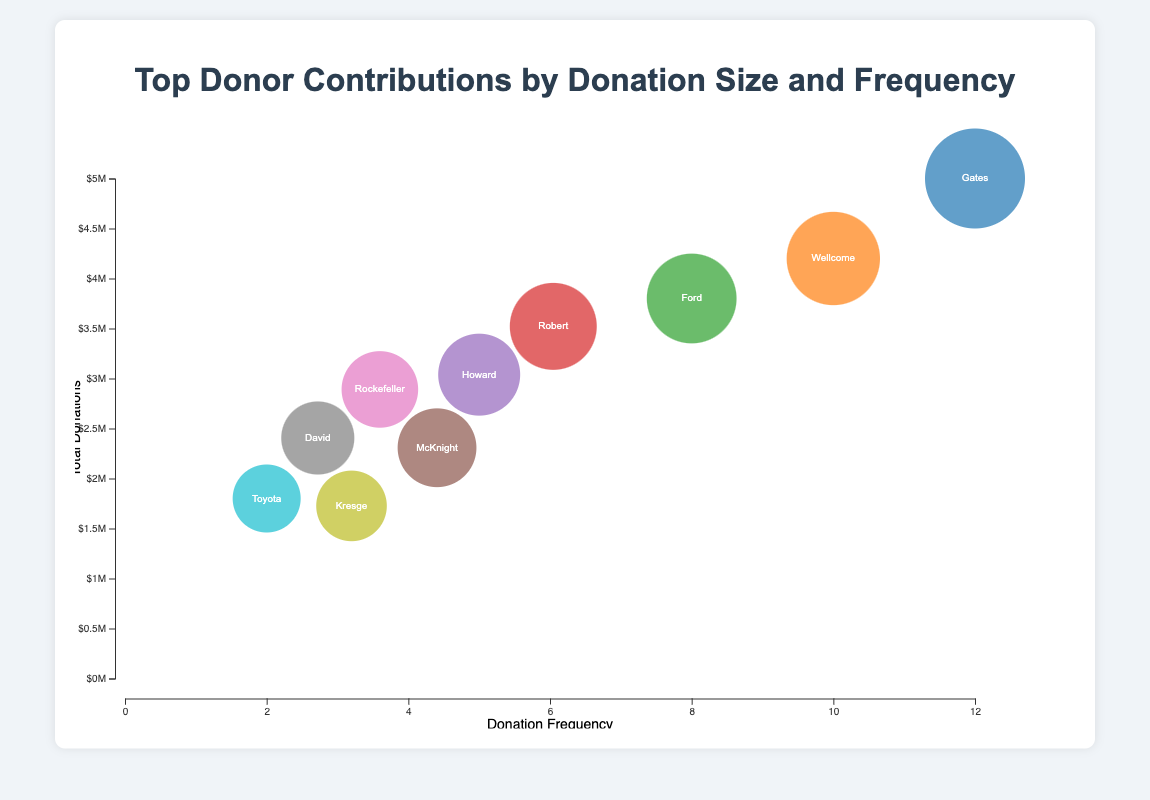What's the name of the donor with the highest total donations? The bubble chart shows various donors with different bubble sizes. The largest bubble represents the donor with the highest total donations. By identifying the largest bubble, which corresponds to the Gates Foundation, we can determine it has the highest total donations.
Answer: Gates Foundation Which donor has the lowest frequency of donations? The bubble chart plots the frequency of donations on the x-axis. The donor with the lowest frequency will be on the far left. The Toyota Foundation is the donor on the far left with a frequency of 2.
Answer: Toyota Foundation What is the total donation value of the donor with a frequency of 4? Look for donors marked with a frequency of 4 on the x-axis. The McKnight Foundation and Rockefeller Foundation both have a frequency of 4. Their donation values are $2,700,000 and $2,500,000 respectively, which can be read directly from the bubbles.
Answer: McKnight Foundation: $2,700,000, Rockefeller Foundation: $2,500,000 Which donors have more than $4,000,000 in total donations? The y-axis represents total donations, with higher positions indicating higher donations. The bubbles above the $4,000,000 mark are for the Gates Foundation and Wellcome Trust.
Answer: Gates Foundation, Wellcome Trust How many donors have a donation frequency higher than 5? The x-axis represents donation frequency. Count the bubbles with a frequency greater than 5. There are three donors: Gates Foundation, Wellcome Trust, and Ford Foundation.
Answer: 3 Which donor contributes more frequently, the Ford Foundation or the Robert Wood Johnson Foundation? Compare the positions of the bubbles for these two foundations along the x-axis. The Ford Foundation has a frequency of 8, while the Robert Wood Johnson Foundation has a frequency of 6.
Answer: Ford Foundation Which donor has a higher total donation amount, the McKnight Foundation or the Howard Hughes Medical Institute? Compare the vertical positions of the bubbles for these two donors on the y-axis. The Howard Hughes Medical Institute is higher with $3,000,000 in total donations compared to the McKnight Foundation's $2,700,000.
Answer: Howard Hughes Medical Institute What's the combined total donations for the donors with a frequency of 3? Identify the donors with a frequency of 3: David and Lucile Packard Foundation and Kresge Foundation. Add their total donations: $2,200,000 + $2,000,000 = $4,200,000.
Answer: $4,200,000 What is the median total donation amount among all donors? First, list all total donations in ascending order: $1,800,000, $2,000,000, $2,200,000, $2,500,000, $2,700,000, $3,000,000, $3,500,000, $3,800,000, $4,200,000, $5,000,000. The median is the middle value, which is the average of the 5th and 6th values: ($2,700,000 + $3,000,000) / 2 = $2,850,000.
Answer: $2,850,000 